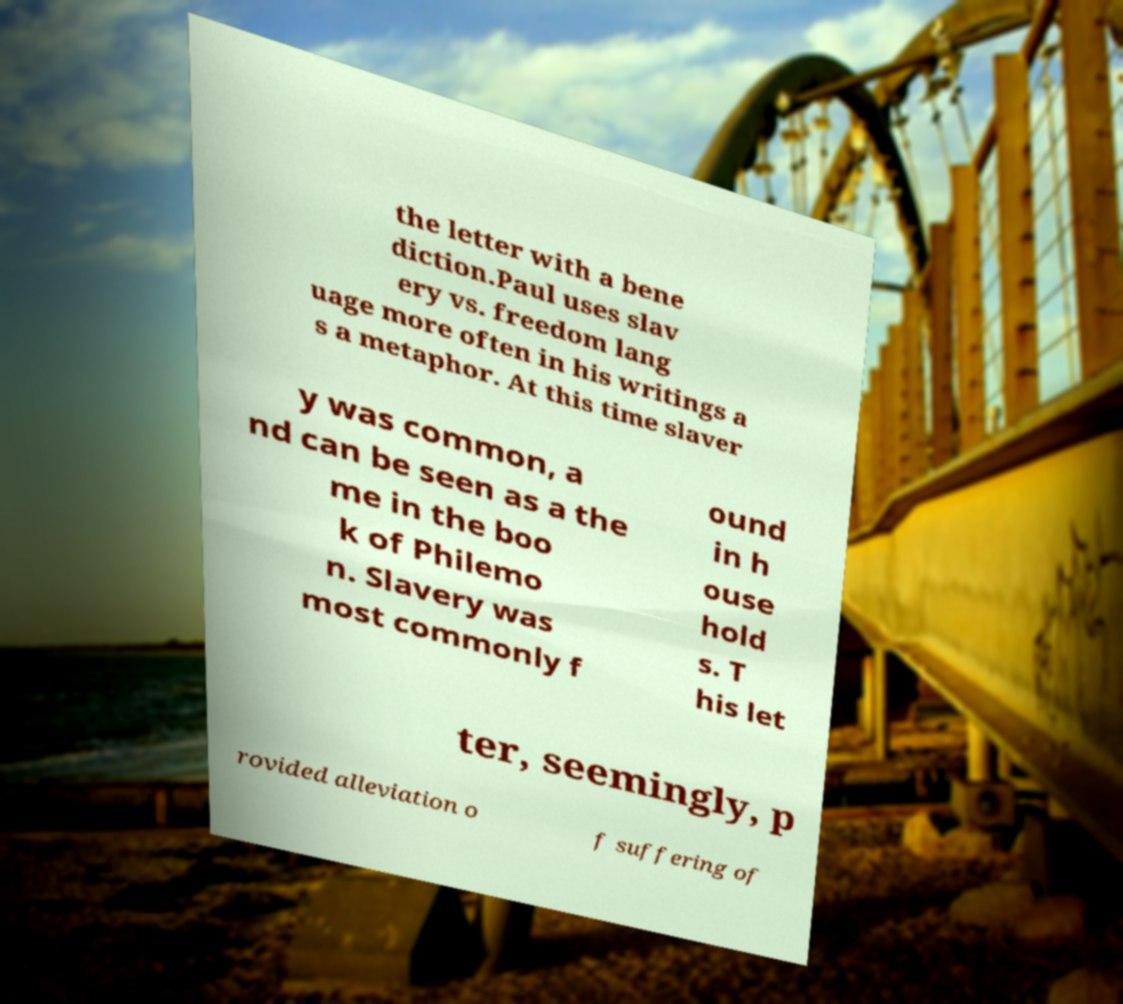Could you extract and type out the text from this image? the letter with a bene diction.Paul uses slav ery vs. freedom lang uage more often in his writings a s a metaphor. At this time slaver y was common, a nd can be seen as a the me in the boo k of Philemo n. Slavery was most commonly f ound in h ouse hold s. T his let ter, seemingly, p rovided alleviation o f suffering of 